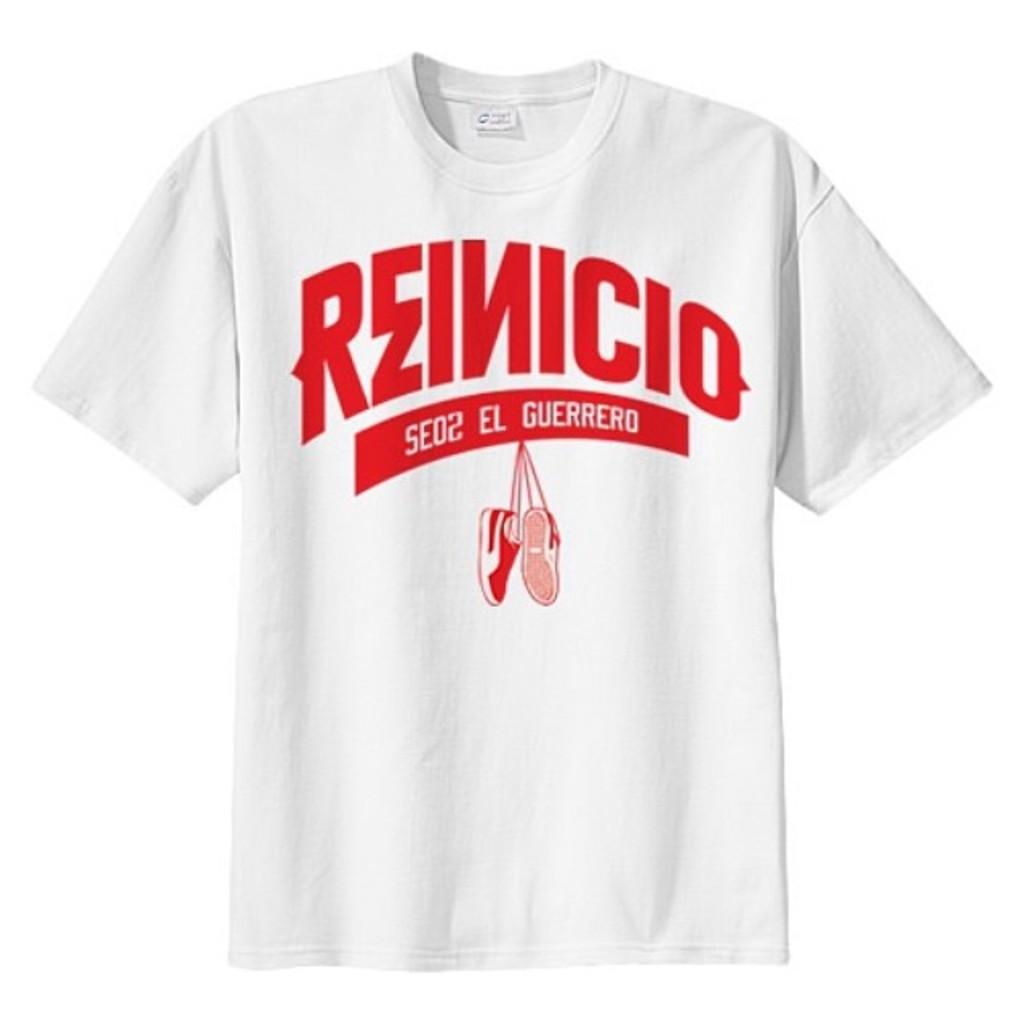<image>
Write a terse but informative summary of the picture. white shirt with reinicio se02el guerrero on it with a pair of shoes hanging down 